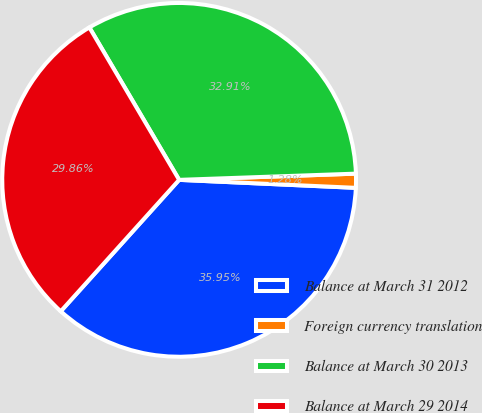<chart> <loc_0><loc_0><loc_500><loc_500><pie_chart><fcel>Balance at March 31 2012<fcel>Foreign currency translation<fcel>Balance at March 30 2013<fcel>Balance at March 29 2014<nl><fcel>35.95%<fcel>1.28%<fcel>32.91%<fcel>29.86%<nl></chart> 